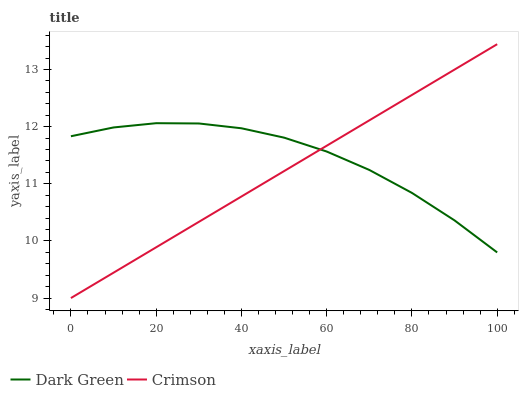Does Crimson have the minimum area under the curve?
Answer yes or no. Yes. Does Dark Green have the maximum area under the curve?
Answer yes or no. Yes. Does Dark Green have the minimum area under the curve?
Answer yes or no. No. Is Crimson the smoothest?
Answer yes or no. Yes. Is Dark Green the roughest?
Answer yes or no. Yes. Is Dark Green the smoothest?
Answer yes or no. No. Does Crimson have the lowest value?
Answer yes or no. Yes. Does Dark Green have the lowest value?
Answer yes or no. No. Does Crimson have the highest value?
Answer yes or no. Yes. Does Dark Green have the highest value?
Answer yes or no. No. Does Dark Green intersect Crimson?
Answer yes or no. Yes. Is Dark Green less than Crimson?
Answer yes or no. No. Is Dark Green greater than Crimson?
Answer yes or no. No. 